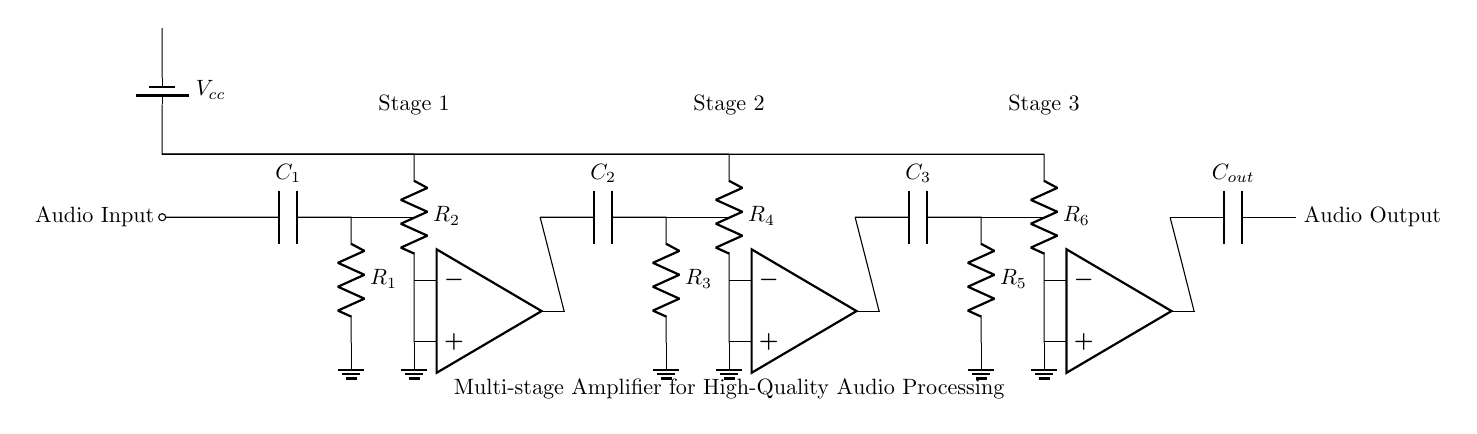What components are used in this amplifier circuit? The circuit contains capacitors, resistors, and operational amplifiers. The specific components are C1, R1, R2, C2, R3, R4, C3, R5, R6, and C_out.
Answer: capacitors, resistors, operational amplifiers How many stages are there in this amplifier circuit? The diagram shows three distinct stages, each consisting of an input capacitor, resistor, and an operational amplifier.
Answer: three What is the purpose of C1 in the circuit? C1 serves as a coupling capacitor in the input stage, allowing AC signals to pass while blocking DC components from the audio input.
Answer: coupling capacitor What is the output connection in this circuit? The output of the circuit is taken from the output of the last operational amplifier (OP3) and connected to C_out, which then leads to the audio output.
Answer: OP3 output to C_out What is the role of R2 in the multi-stage amplifier? R2 acts as a feedback resistor for the first stage operational amplifier, helping to set the gain of that stage by controlling the feedback loop's resistance.
Answer: feedback resistor What is the voltage supply for this circuit? The voltage supply is indicated by Vcc, which powers the operational amplifiers in the circuit.
Answer: Vcc What does each stage of amplification do in this circuit? Each stage amplifies the audio signal progressively, with the first stage boosting the input signal, the second stage providing additional gain, and the third stage finalizing the output for high-quality processing.
Answer: amplifies audio signal 